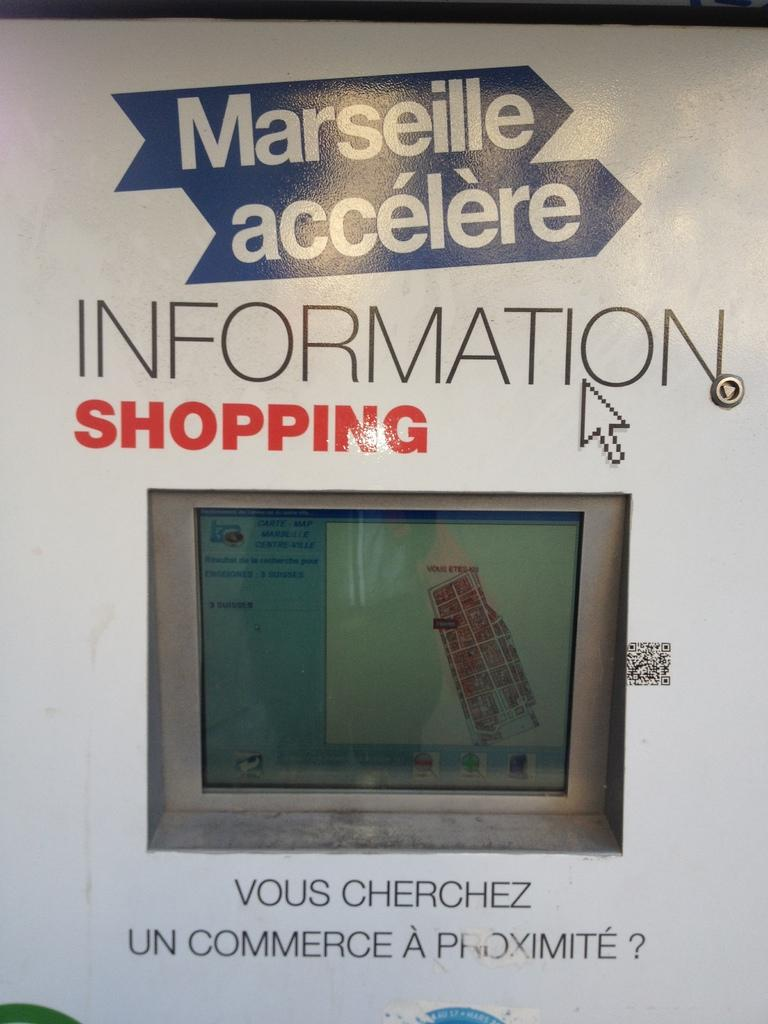<image>
Offer a succinct explanation of the picture presented. A gray and blue screen with a design shown on it and up top the words Information shopping. 